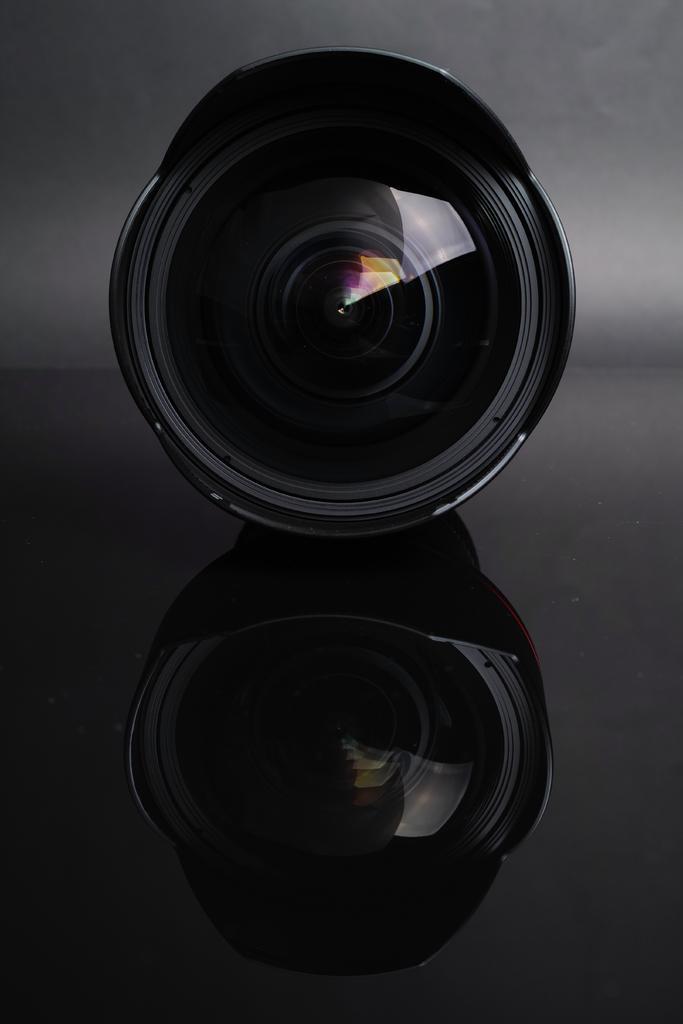Describe this image in one or two sentences. In this image we can see a camera which is placed on the surface. 